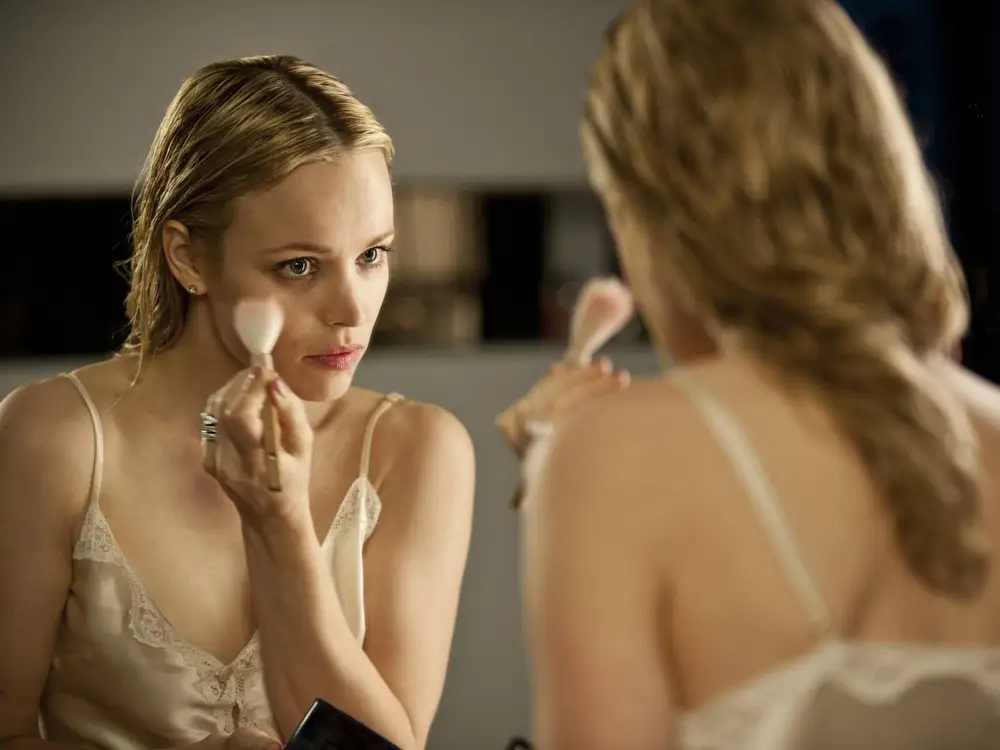Can you describe the significance of the makeup application in this setting? The makeup application in this setting signifies a moment of personal preparation, possibly before a significant event. It is a ritual that not only enhances physical appearance but also prepares the individual mentally and emotionally. The meticulous nature of the task and the intimate environment suggest a personal transformation and a preparation for a role or a public appearance. 